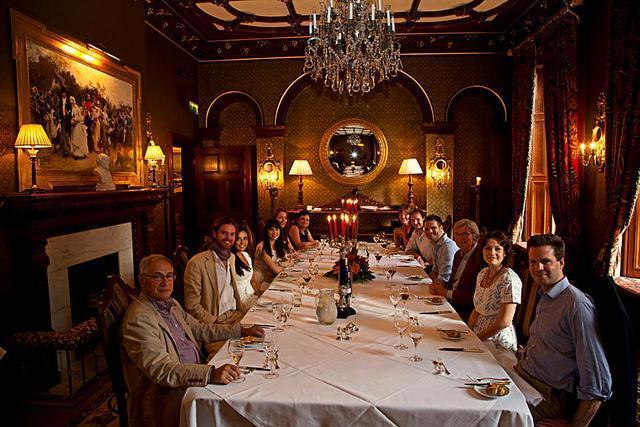How many people are there?
Give a very brief answer. 5. How many chairs can be seen?
Give a very brief answer. 2. 